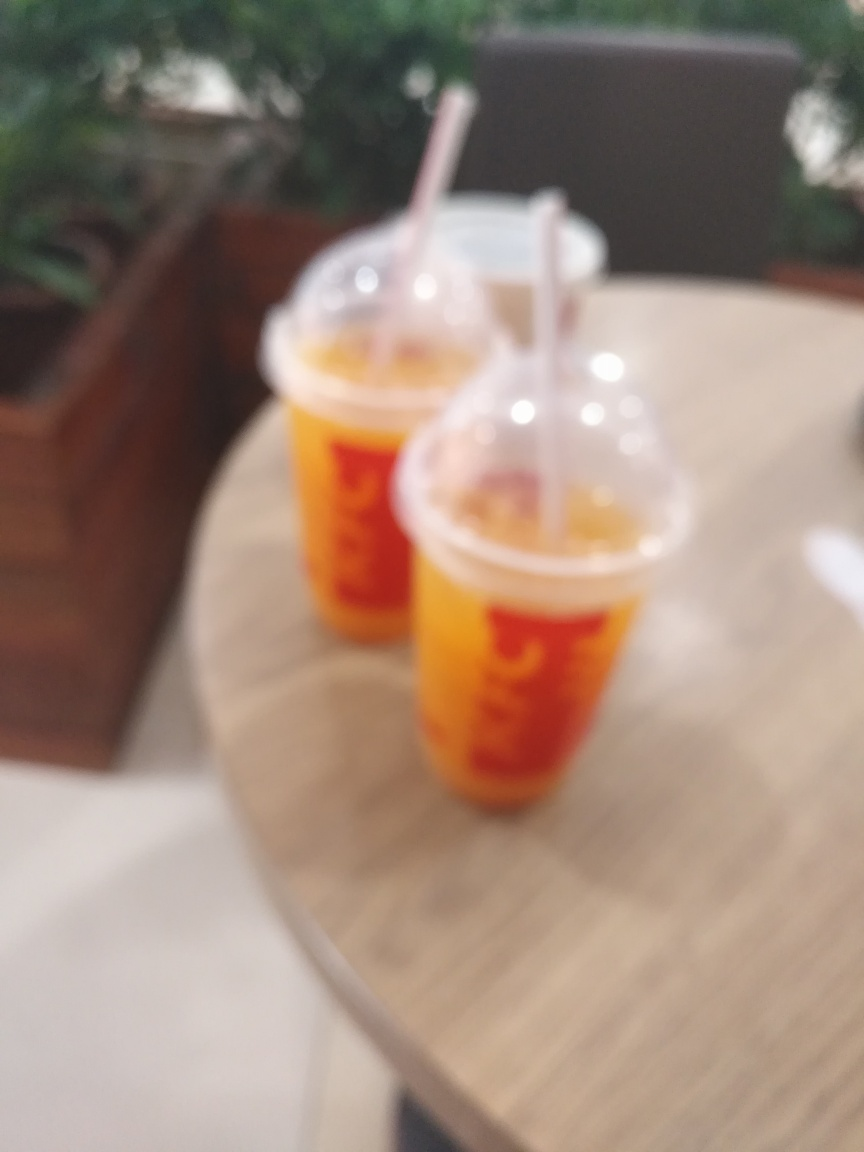What details has the main subject lost?
A. Color
B. Size
C. Texture
Answer with the option's letter from the given choices directly. Based on the blurred image, it's challenging to make out the fine details that would indicate texture. Therefore, the main subject has most prominently lost clarity in texture, which includes intricate patterns, the nature of surfaces, and specific material characteristics. It's the sharpness and intricacies normally seen in a focused image that are missing here. 